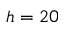Convert formula to latex. <formula><loc_0><loc_0><loc_500><loc_500>h = 2 0</formula> 